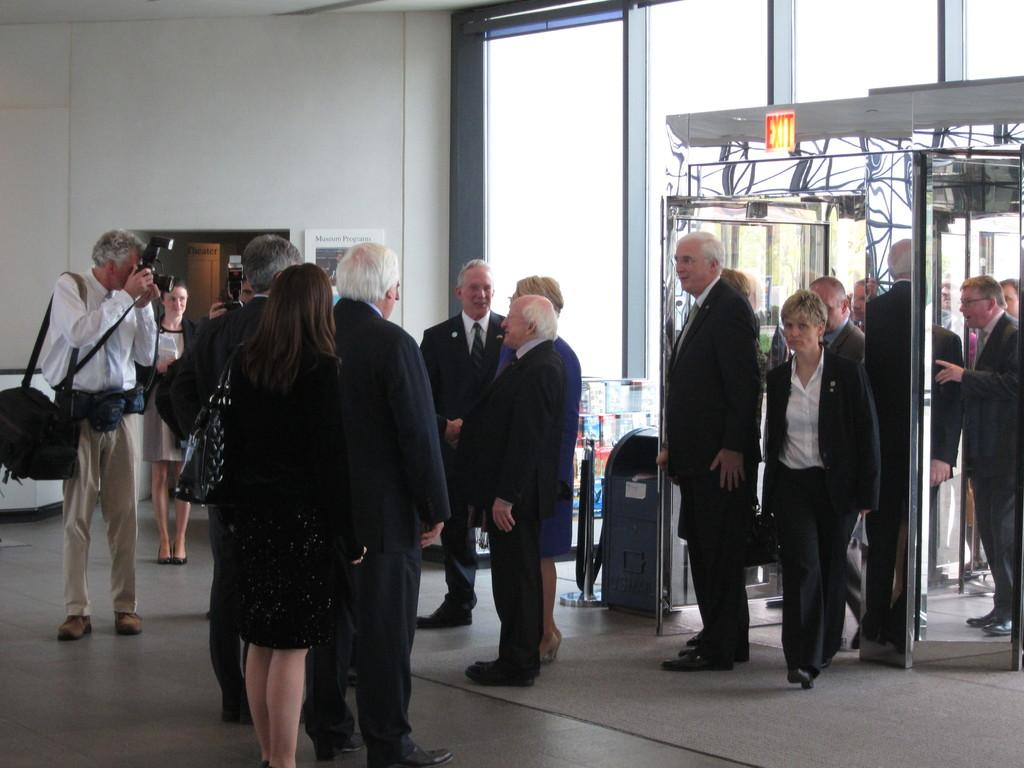How many people are in the image? There are many people in the image. What are the people wearing? The people are wearing black suits. What is at the bottom of the image? There is a floor at the bottom of the image. What can be seen in the background of the image? There is a wall and a door in the background of the image. Which direction are the people blowing in the image? There is no blowing or wind present in the image; the people are simply standing or walking. 